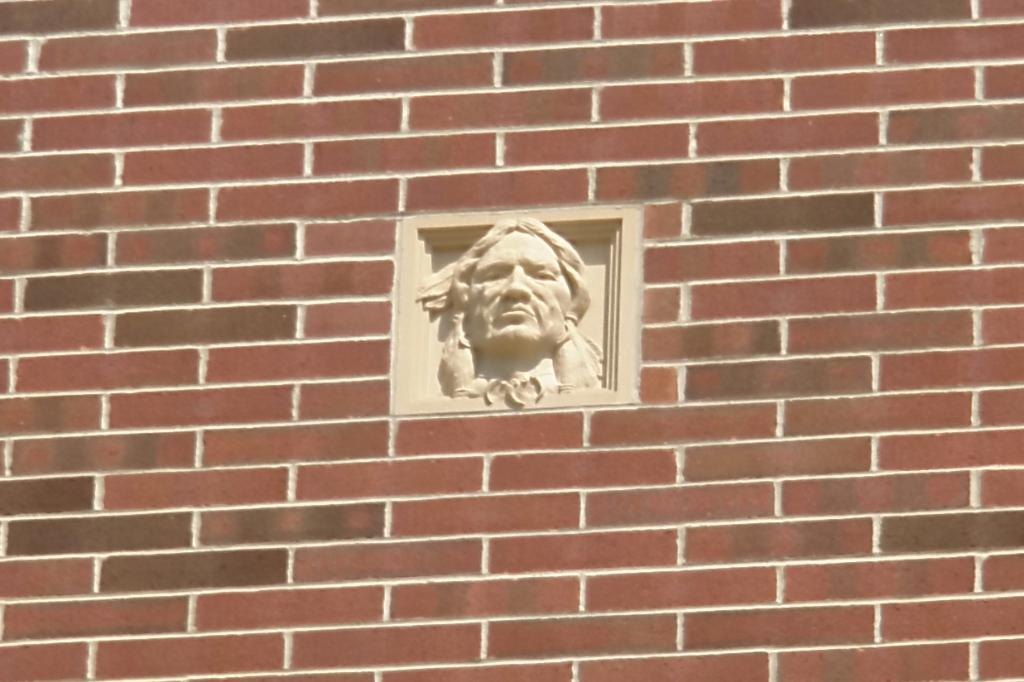What is the main subject of the image? There is a sculpture on the wall in the image. Can you describe the sculpture? Unfortunately, the description of the sculpture is not provided in the facts. However, we can say that it is a sculpture and it is on the wall. What type of artwork is depicted in the image? Based on the fact provided, we can say that the artwork is a sculpture. How does the sculpture shake hands with the porter in the image? There is no porter present in the image, and sculptures cannot shake hands. 